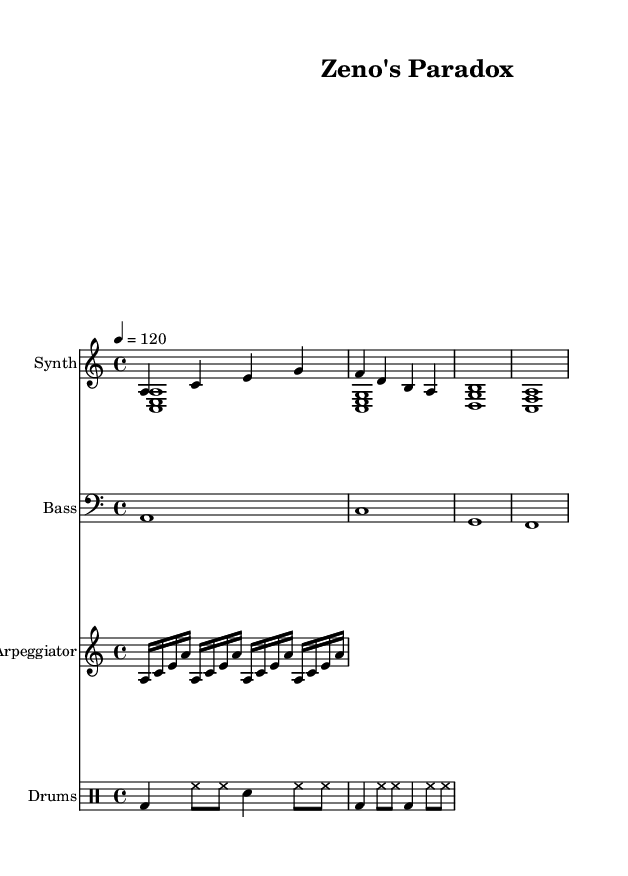What is the key signature of this music? The key signature is identified at the beginning of the staff. It shows an "A minor" key signature, which has no sharps or flats.
Answer: A minor What is the time signature of this music? The time signature is found at the beginning as well, represented by "4/4," indicating there are four beats in a measure and the quarter note gets one beat.
Answer: 4/4 What is the tempo of this composition? The tempo is indicated "4 = 120," meaning the quarter note is set to a speed of 120 beats per minute, directing how fast the piece should be played.
Answer: 120 How many measures are in the melody section? Counting the distinct groups of notes in the melody line helps find the total measures. In this case, there are four distinct groupings, indicating four measures.
Answer: 4 What is the highest note in the melody? To find the highest note, one must examine the melody line. The notes range from A to G, with G being the highest note shown in this melody.
Answer: G What type of instrument is primarily used for the melody? The title of the staff at the top indicates the instrument used for the melody as "Synth," suggesting an electronic sound.
Answer: Synth What rhythmic pattern do the drums follow? The drum pattern can be examined in the drum staff, where the sequences of bass and hi-hat notes depict a repetitive rhythm. The pattern alternates between two distinct sections as detailed in the code.
Answer: Alternating 